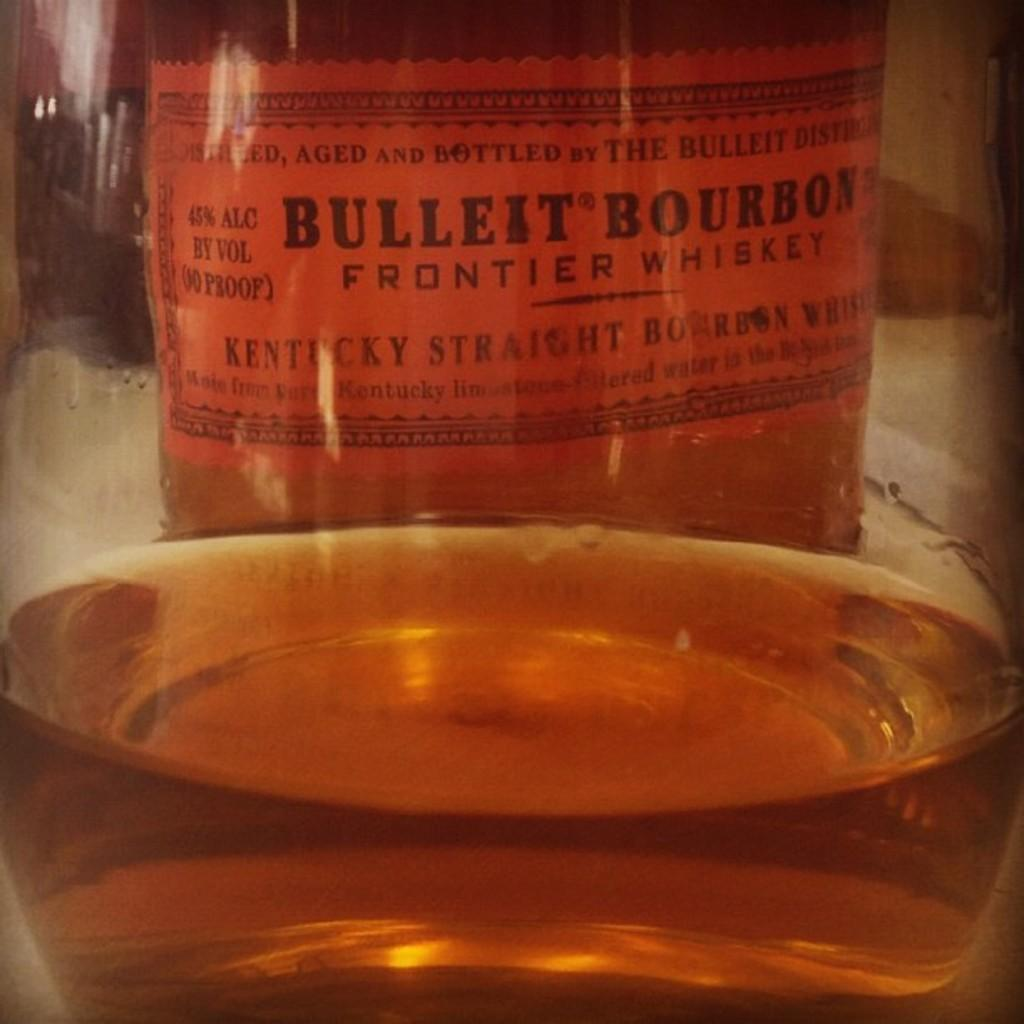<image>
Provide a brief description of the given image. A glass full ob Bulleit Bourbon Frontier Whiskey, an orange labelled bottle. 